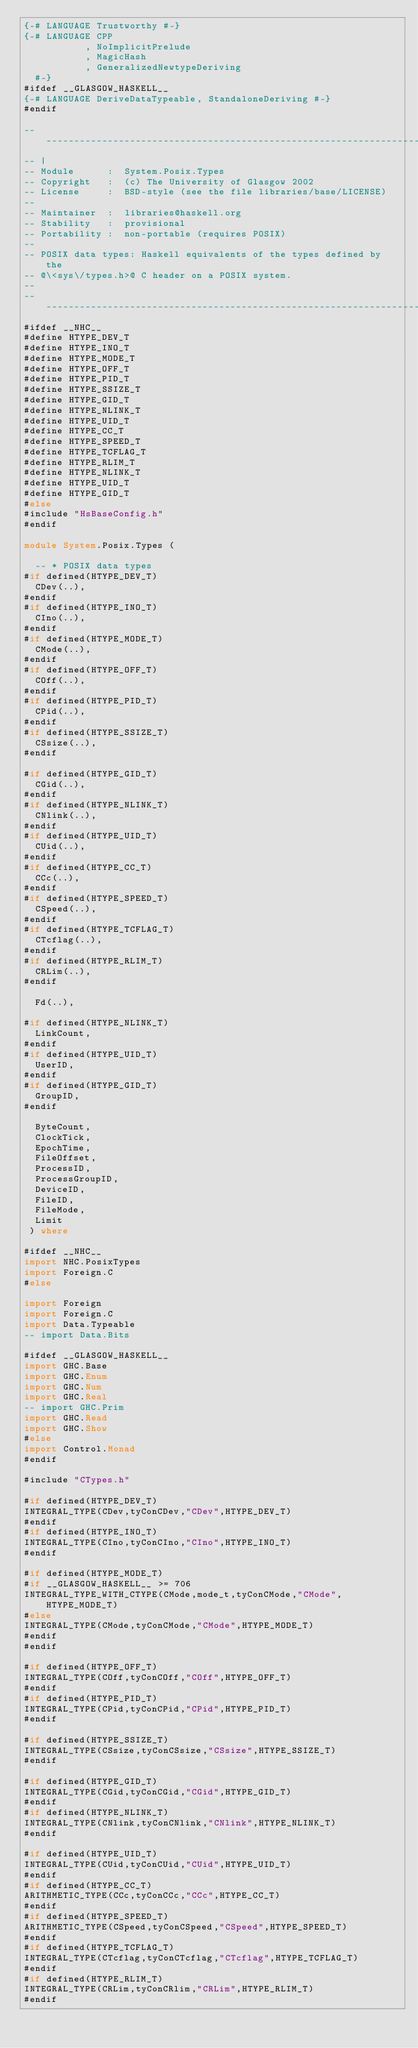<code> <loc_0><loc_0><loc_500><loc_500><_Haskell_>{-# LANGUAGE Trustworthy #-}
{-# LANGUAGE CPP
           , NoImplicitPrelude
           , MagicHash
           , GeneralizedNewtypeDeriving
  #-}
#ifdef __GLASGOW_HASKELL__
{-# LANGUAGE DeriveDataTypeable, StandaloneDeriving #-}
#endif

-----------------------------------------------------------------------------
-- |
-- Module      :  System.Posix.Types
-- Copyright   :  (c) The University of Glasgow 2002
-- License     :  BSD-style (see the file libraries/base/LICENSE)
-- 
-- Maintainer  :  libraries@haskell.org
-- Stability   :  provisional
-- Portability :  non-portable (requires POSIX)
--
-- POSIX data types: Haskell equivalents of the types defined by the
-- @\<sys\/types.h>@ C header on a POSIX system.
--
-----------------------------------------------------------------------------
#ifdef __NHC__
#define HTYPE_DEV_T
#define HTYPE_INO_T
#define HTYPE_MODE_T
#define HTYPE_OFF_T
#define HTYPE_PID_T
#define HTYPE_SSIZE_T
#define HTYPE_GID_T
#define HTYPE_NLINK_T
#define HTYPE_UID_T
#define HTYPE_CC_T
#define HTYPE_SPEED_T
#define HTYPE_TCFLAG_T
#define HTYPE_RLIM_T
#define HTYPE_NLINK_T
#define HTYPE_UID_T
#define HTYPE_GID_T
#else
#include "HsBaseConfig.h"
#endif

module System.Posix.Types (

  -- * POSIX data types
#if defined(HTYPE_DEV_T)
  CDev(..),
#endif
#if defined(HTYPE_INO_T)
  CIno(..),
#endif
#if defined(HTYPE_MODE_T)
  CMode(..),
#endif
#if defined(HTYPE_OFF_T)
  COff(..),
#endif
#if defined(HTYPE_PID_T)
  CPid(..),
#endif
#if defined(HTYPE_SSIZE_T)
  CSsize(..),
#endif

#if defined(HTYPE_GID_T)
  CGid(..),
#endif
#if defined(HTYPE_NLINK_T)
  CNlink(..),
#endif
#if defined(HTYPE_UID_T)
  CUid(..),
#endif
#if defined(HTYPE_CC_T)
  CCc(..),
#endif
#if defined(HTYPE_SPEED_T)
  CSpeed(..),
#endif
#if defined(HTYPE_TCFLAG_T)
  CTcflag(..),
#endif
#if defined(HTYPE_RLIM_T)
  CRLim(..),
#endif

  Fd(..),

#if defined(HTYPE_NLINK_T)
  LinkCount,
#endif
#if defined(HTYPE_UID_T)
  UserID,
#endif
#if defined(HTYPE_GID_T)
  GroupID,
#endif

  ByteCount,
  ClockTick,
  EpochTime,
  FileOffset,
  ProcessID,
  ProcessGroupID,
  DeviceID,
  FileID,
  FileMode,
  Limit
 ) where

#ifdef __NHC__
import NHC.PosixTypes
import Foreign.C
#else

import Foreign
import Foreign.C
import Data.Typeable
-- import Data.Bits

#ifdef __GLASGOW_HASKELL__
import GHC.Base
import GHC.Enum
import GHC.Num
import GHC.Real
-- import GHC.Prim
import GHC.Read
import GHC.Show
#else
import Control.Monad
#endif

#include "CTypes.h"

#if defined(HTYPE_DEV_T)
INTEGRAL_TYPE(CDev,tyConCDev,"CDev",HTYPE_DEV_T)
#endif
#if defined(HTYPE_INO_T)
INTEGRAL_TYPE(CIno,tyConCIno,"CIno",HTYPE_INO_T)
#endif

#if defined(HTYPE_MODE_T)
#if __GLASGOW_HASKELL__ >= 706
INTEGRAL_TYPE_WITH_CTYPE(CMode,mode_t,tyConCMode,"CMode",HTYPE_MODE_T)
#else
INTEGRAL_TYPE(CMode,tyConCMode,"CMode",HTYPE_MODE_T)
#endif
#endif

#if defined(HTYPE_OFF_T)
INTEGRAL_TYPE(COff,tyConCOff,"COff",HTYPE_OFF_T)
#endif
#if defined(HTYPE_PID_T)
INTEGRAL_TYPE(CPid,tyConCPid,"CPid",HTYPE_PID_T)
#endif

#if defined(HTYPE_SSIZE_T)
INTEGRAL_TYPE(CSsize,tyConCSsize,"CSsize",HTYPE_SSIZE_T)
#endif

#if defined(HTYPE_GID_T)
INTEGRAL_TYPE(CGid,tyConCGid,"CGid",HTYPE_GID_T)
#endif
#if defined(HTYPE_NLINK_T)
INTEGRAL_TYPE(CNlink,tyConCNlink,"CNlink",HTYPE_NLINK_T)
#endif

#if defined(HTYPE_UID_T)
INTEGRAL_TYPE(CUid,tyConCUid,"CUid",HTYPE_UID_T)
#endif
#if defined(HTYPE_CC_T)
ARITHMETIC_TYPE(CCc,tyConCCc,"CCc",HTYPE_CC_T)
#endif
#if defined(HTYPE_SPEED_T)
ARITHMETIC_TYPE(CSpeed,tyConCSpeed,"CSpeed",HTYPE_SPEED_T)
#endif
#if defined(HTYPE_TCFLAG_T)
INTEGRAL_TYPE(CTcflag,tyConCTcflag,"CTcflag",HTYPE_TCFLAG_T)
#endif
#if defined(HTYPE_RLIM_T)
INTEGRAL_TYPE(CRLim,tyConCRlim,"CRLim",HTYPE_RLIM_T)
#endif
</code> 